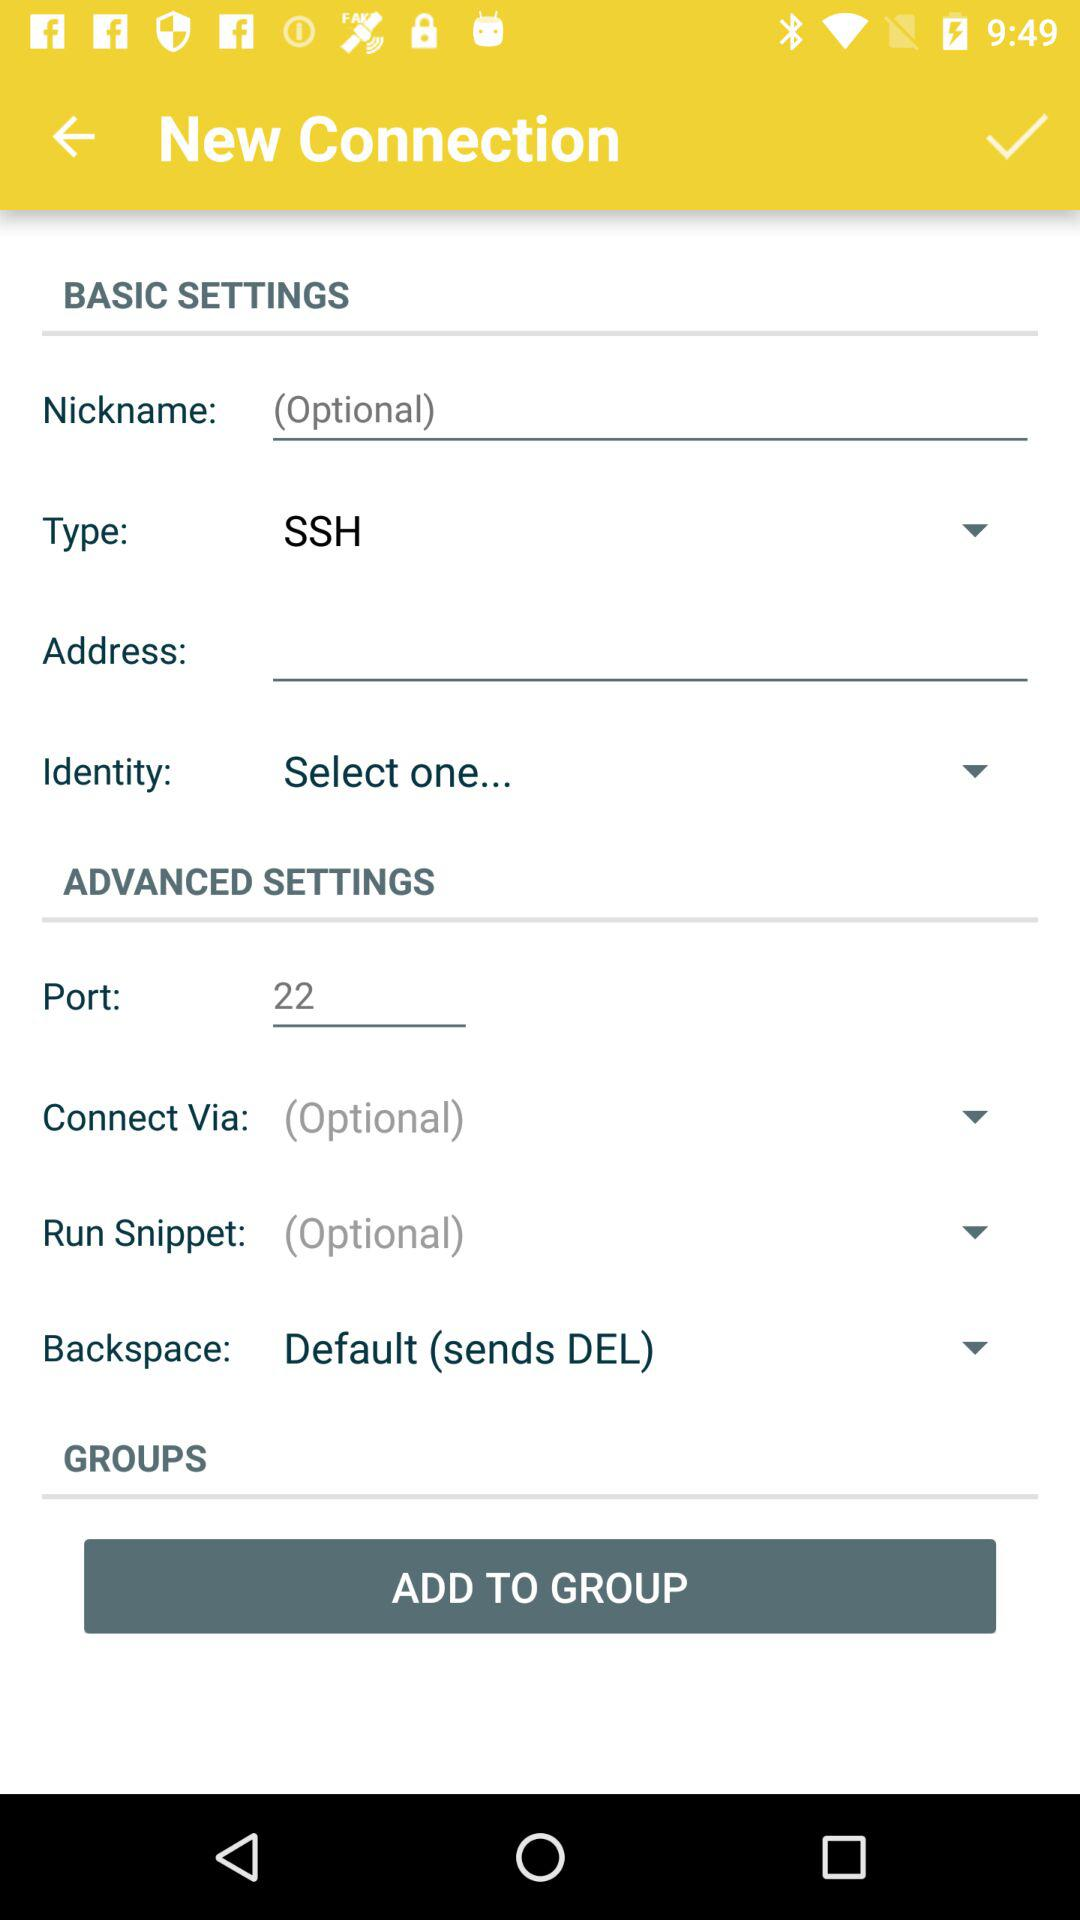What's the port number? The port number is 22. 